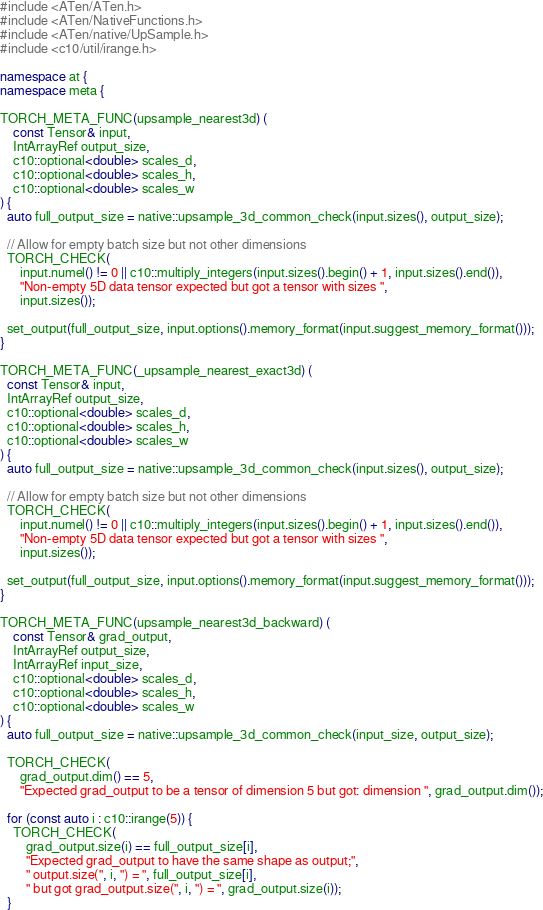Convert code to text. <code><loc_0><loc_0><loc_500><loc_500><_C++_>#include <ATen/ATen.h>
#include <ATen/NativeFunctions.h>
#include <ATen/native/UpSample.h>
#include <c10/util/irange.h>

namespace at {
namespace meta {

TORCH_META_FUNC(upsample_nearest3d) (
    const Tensor& input,
    IntArrayRef output_size,
    c10::optional<double> scales_d,
    c10::optional<double> scales_h,
    c10::optional<double> scales_w
) {
  auto full_output_size = native::upsample_3d_common_check(input.sizes(), output_size);

  // Allow for empty batch size but not other dimensions
  TORCH_CHECK(
      input.numel() != 0 || c10::multiply_integers(input.sizes().begin() + 1, input.sizes().end()),
      "Non-empty 5D data tensor expected but got a tensor with sizes ",
      input.sizes());

  set_output(full_output_size, input.options().memory_format(input.suggest_memory_format()));
}

TORCH_META_FUNC(_upsample_nearest_exact3d) (
  const Tensor& input,
  IntArrayRef output_size,
  c10::optional<double> scales_d,
  c10::optional<double> scales_h,
  c10::optional<double> scales_w
) {
  auto full_output_size = native::upsample_3d_common_check(input.sizes(), output_size);

  // Allow for empty batch size but not other dimensions
  TORCH_CHECK(
      input.numel() != 0 || c10::multiply_integers(input.sizes().begin() + 1, input.sizes().end()),
      "Non-empty 5D data tensor expected but got a tensor with sizes ",
      input.sizes());

  set_output(full_output_size, input.options().memory_format(input.suggest_memory_format()));
}

TORCH_META_FUNC(upsample_nearest3d_backward) (
    const Tensor& grad_output,
    IntArrayRef output_size,
    IntArrayRef input_size,
    c10::optional<double> scales_d,
    c10::optional<double> scales_h,
    c10::optional<double> scales_w
) {
  auto full_output_size = native::upsample_3d_common_check(input_size, output_size);

  TORCH_CHECK(
      grad_output.dim() == 5,
      "Expected grad_output to be a tensor of dimension 5 but got: dimension ", grad_output.dim());

  for (const auto i : c10::irange(5)) {
    TORCH_CHECK(
        grad_output.size(i) == full_output_size[i],
        "Expected grad_output to have the same shape as output;",
        " output.size(", i, ") = ", full_output_size[i],
        " but got grad_output.size(", i, ") = ", grad_output.size(i));
  }
</code> 